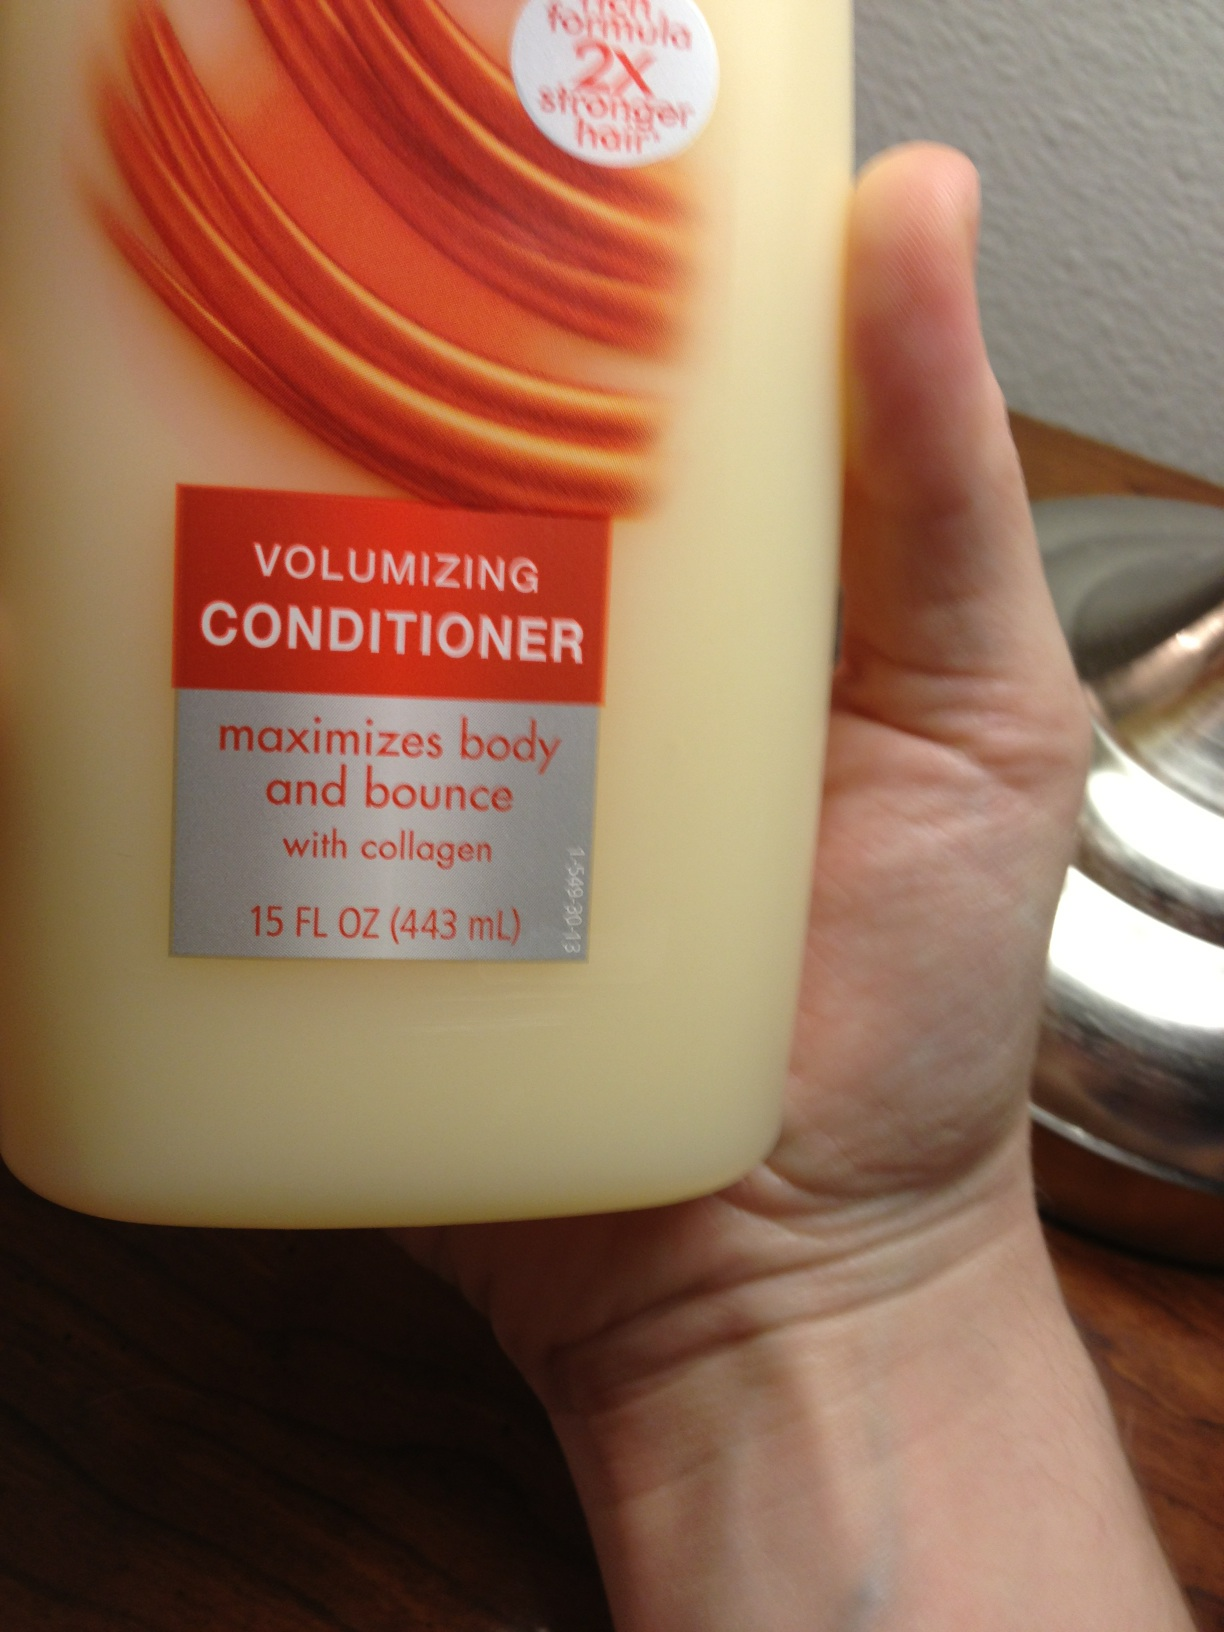What are the benefits of using a volumizing conditioner? Volumizing conditioners, such as the one pictured, are formulated to help give hair more volume, enhancding its thickness and fullness. They may contain special proteins like collagen to strengthen the hair and improve its overall texture and appearance. 